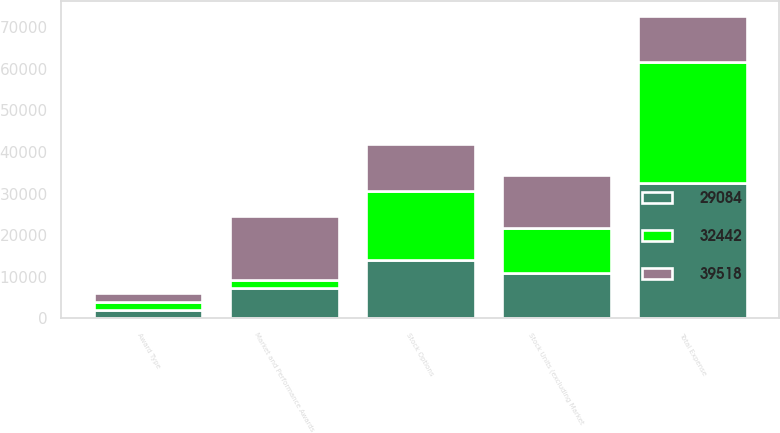Convert chart to OTSL. <chart><loc_0><loc_0><loc_500><loc_500><stacked_bar_chart><ecel><fcel>Award Type<fcel>Stock Units (excluding Market<fcel>Stock Options<fcel>Market and Performance Awards<fcel>Total Expense<nl><fcel>39518<fcel>2013<fcel>12836<fcel>11385<fcel>15297<fcel>11203<nl><fcel>29084<fcel>2012<fcel>11021<fcel>14067<fcel>7354<fcel>32442<nl><fcel>32442<fcel>2011<fcel>10710<fcel>16468<fcel>1906<fcel>29084<nl></chart> 